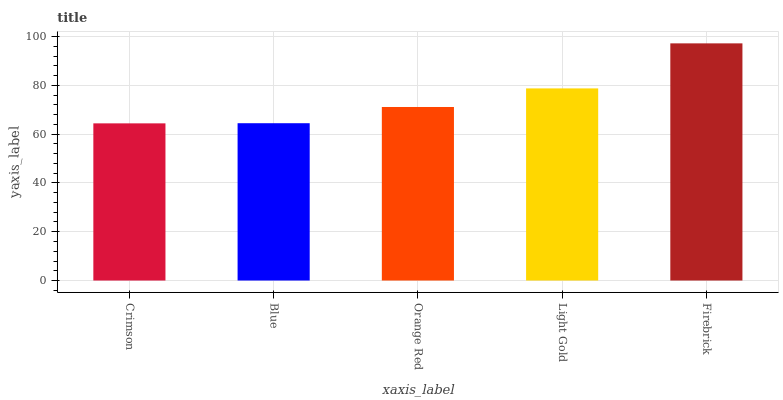Is Crimson the minimum?
Answer yes or no. Yes. Is Firebrick the maximum?
Answer yes or no. Yes. Is Blue the minimum?
Answer yes or no. No. Is Blue the maximum?
Answer yes or no. No. Is Blue greater than Crimson?
Answer yes or no. Yes. Is Crimson less than Blue?
Answer yes or no. Yes. Is Crimson greater than Blue?
Answer yes or no. No. Is Blue less than Crimson?
Answer yes or no. No. Is Orange Red the high median?
Answer yes or no. Yes. Is Orange Red the low median?
Answer yes or no. Yes. Is Blue the high median?
Answer yes or no. No. Is Firebrick the low median?
Answer yes or no. No. 